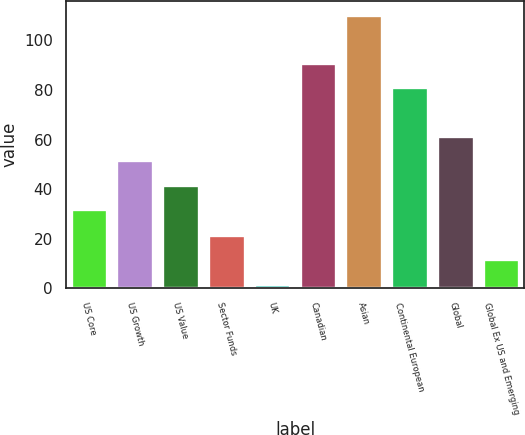Convert chart to OTSL. <chart><loc_0><loc_0><loc_500><loc_500><bar_chart><fcel>US Core<fcel>US Growth<fcel>US Value<fcel>Sector Funds<fcel>UK<fcel>Canadian<fcel>Asian<fcel>Continental European<fcel>Global<fcel>Global Ex US and Emerging<nl><fcel>32<fcel>51.6<fcel>41.8<fcel>21.6<fcel>2<fcel>90.8<fcel>110.4<fcel>81<fcel>61.4<fcel>11.8<nl></chart> 